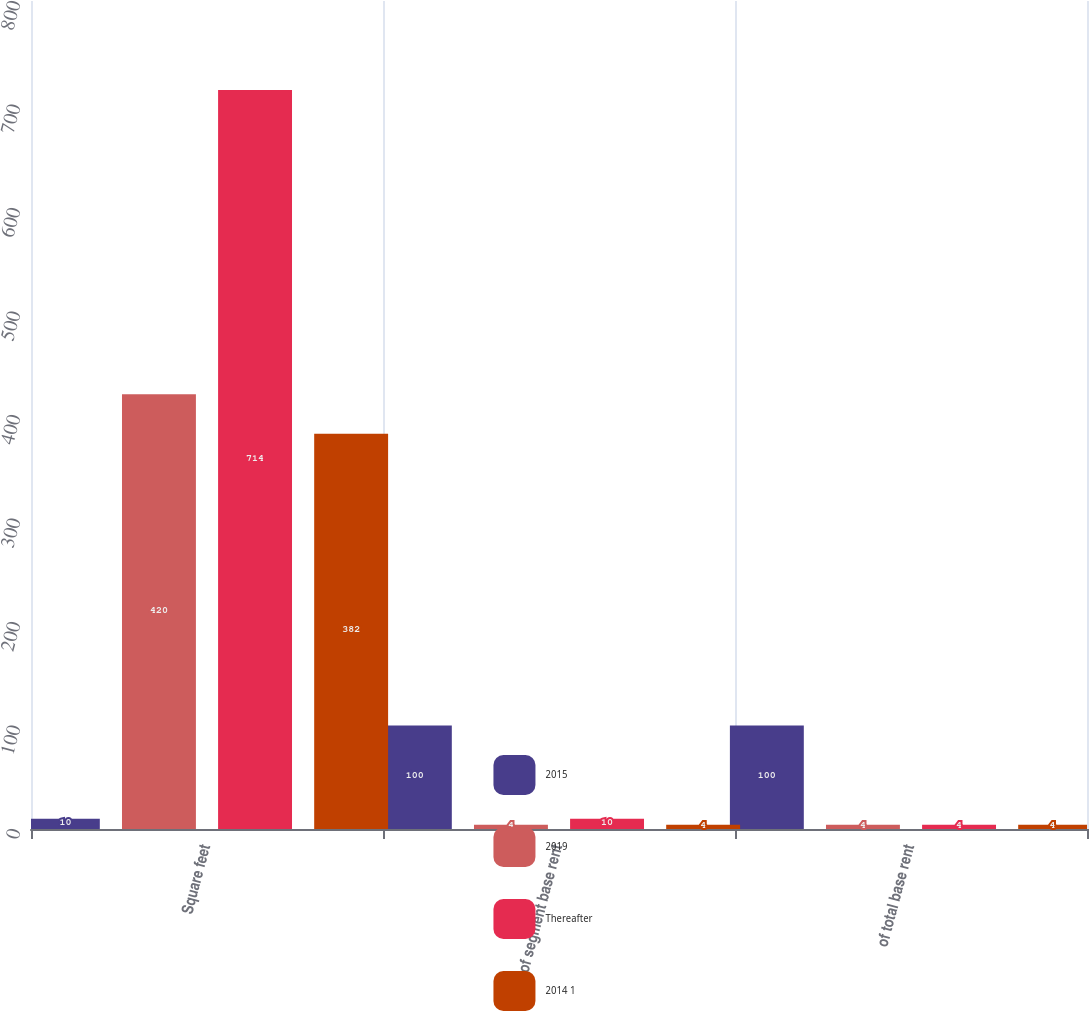Convert chart to OTSL. <chart><loc_0><loc_0><loc_500><loc_500><stacked_bar_chart><ecel><fcel>Square feet<fcel>of segment base rent<fcel>of total base rent<nl><fcel>2015<fcel>10<fcel>100<fcel>100<nl><fcel>2019<fcel>420<fcel>4<fcel>4<nl><fcel>Thereafter<fcel>714<fcel>10<fcel>4<nl><fcel>2014 1<fcel>382<fcel>4<fcel>4<nl></chart> 